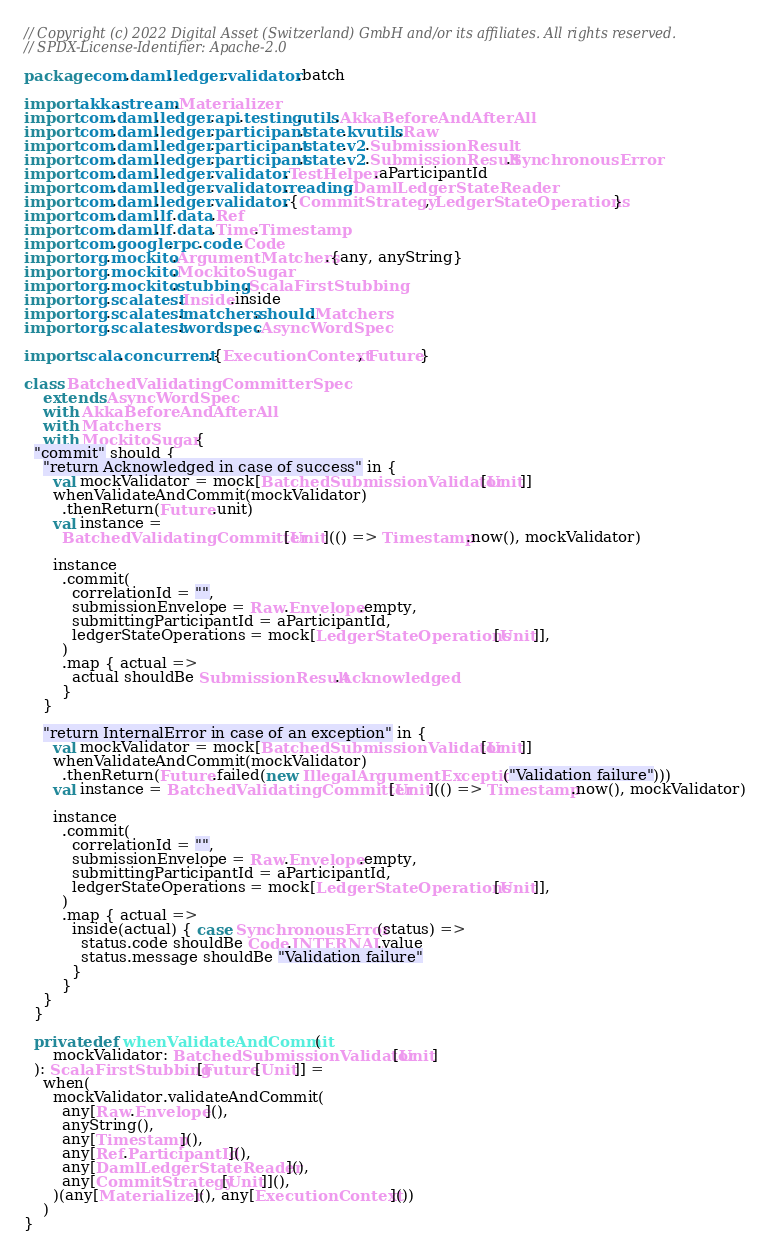<code> <loc_0><loc_0><loc_500><loc_500><_Scala_>// Copyright (c) 2022 Digital Asset (Switzerland) GmbH and/or its affiliates. All rights reserved.
// SPDX-License-Identifier: Apache-2.0

package com.daml.ledger.validator.batch

import akka.stream.Materializer
import com.daml.ledger.api.testing.utils.AkkaBeforeAndAfterAll
import com.daml.ledger.participant.state.kvutils.Raw
import com.daml.ledger.participant.state.v2.SubmissionResult
import com.daml.ledger.participant.state.v2.SubmissionResult.SynchronousError
import com.daml.ledger.validator.TestHelper.aParticipantId
import com.daml.ledger.validator.reading.DamlLedgerStateReader
import com.daml.ledger.validator.{CommitStrategy, LedgerStateOperations}
import com.daml.lf.data.Ref
import com.daml.lf.data.Time.Timestamp
import com.google.rpc.code.Code
import org.mockito.ArgumentMatchers.{any, anyString}
import org.mockito.MockitoSugar
import org.mockito.stubbing.ScalaFirstStubbing
import org.scalatest.Inside.inside
import org.scalatest.matchers.should.Matchers
import org.scalatest.wordspec.AsyncWordSpec

import scala.concurrent.{ExecutionContext, Future}

class BatchedValidatingCommitterSpec
    extends AsyncWordSpec
    with AkkaBeforeAndAfterAll
    with Matchers
    with MockitoSugar {
  "commit" should {
    "return Acknowledged in case of success" in {
      val mockValidator = mock[BatchedSubmissionValidator[Unit]]
      whenValidateAndCommit(mockValidator)
        .thenReturn(Future.unit)
      val instance =
        BatchedValidatingCommitter[Unit](() => Timestamp.now(), mockValidator)

      instance
        .commit(
          correlationId = "",
          submissionEnvelope = Raw.Envelope.empty,
          submittingParticipantId = aParticipantId,
          ledgerStateOperations = mock[LedgerStateOperations[Unit]],
        )
        .map { actual =>
          actual shouldBe SubmissionResult.Acknowledged
        }
    }

    "return InternalError in case of an exception" in {
      val mockValidator = mock[BatchedSubmissionValidator[Unit]]
      whenValidateAndCommit(mockValidator)
        .thenReturn(Future.failed(new IllegalArgumentException("Validation failure")))
      val instance = BatchedValidatingCommitter[Unit](() => Timestamp.now(), mockValidator)

      instance
        .commit(
          correlationId = "",
          submissionEnvelope = Raw.Envelope.empty,
          submittingParticipantId = aParticipantId,
          ledgerStateOperations = mock[LedgerStateOperations[Unit]],
        )
        .map { actual =>
          inside(actual) { case SynchronousError(status) =>
            status.code shouldBe Code.INTERNAL.value
            status.message shouldBe "Validation failure"
          }
        }
    }
  }

  private def whenValidateAndCommit(
      mockValidator: BatchedSubmissionValidator[Unit]
  ): ScalaFirstStubbing[Future[Unit]] =
    when(
      mockValidator.validateAndCommit(
        any[Raw.Envelope](),
        anyString(),
        any[Timestamp](),
        any[Ref.ParticipantId](),
        any[DamlLedgerStateReader](),
        any[CommitStrategy[Unit]](),
      )(any[Materializer](), any[ExecutionContext]())
    )
}
</code> 